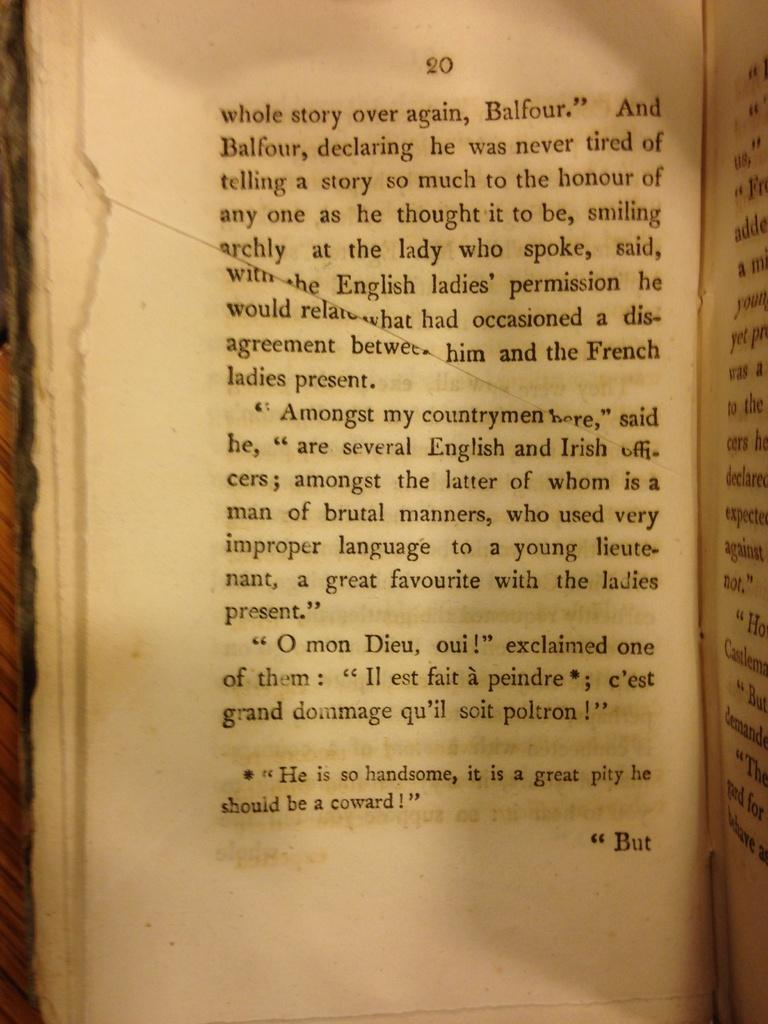<image>
Render a clear and concise summary of the photo. Page 20 of an old book, describing a character named Balfour. 